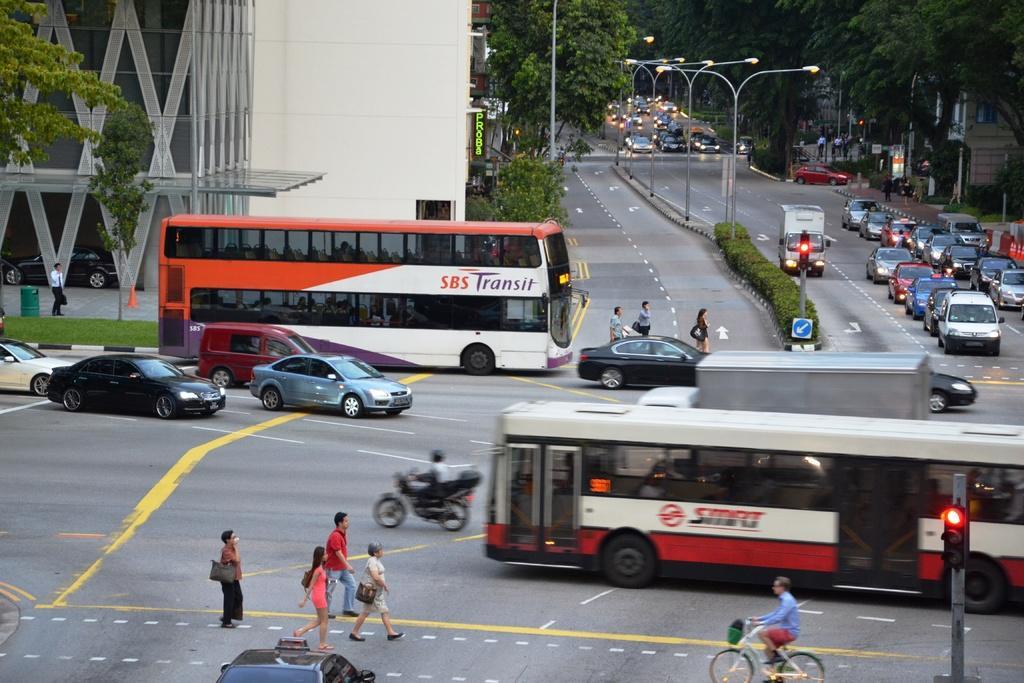Can you describe this image briefly? In this image there are few cars and vehicles are on the road. A person is sitting on the bike and riding on the road. Few persons are walking on the road. Bottom of the image there is a person wearing blue shirt is sitting and riding a bicycle on the road. There is a pole having a traffic light attached to it. Left side a person is walking on the pavement having dustbin on it. There are few street lights and few plants , before it there is a pole having few boards and a traffic light is attached to it. Background there are few trees and buildings. 